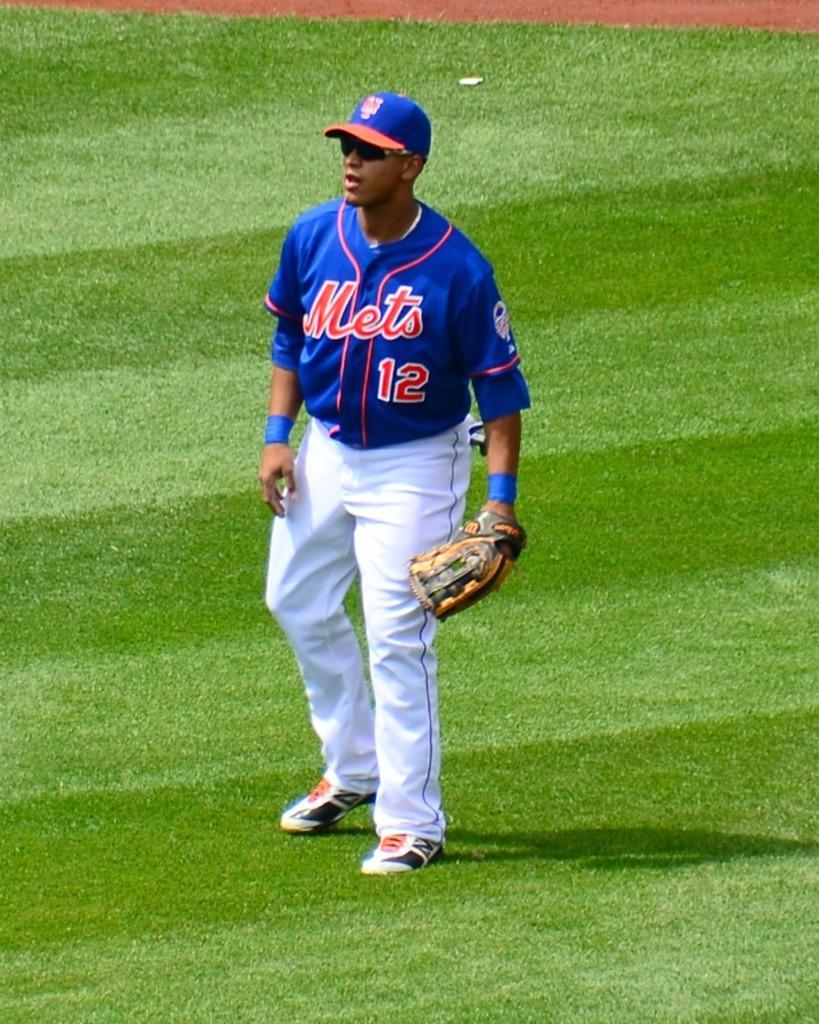Can you describe this image briefly? In this image we can see a man standing on the ground. 